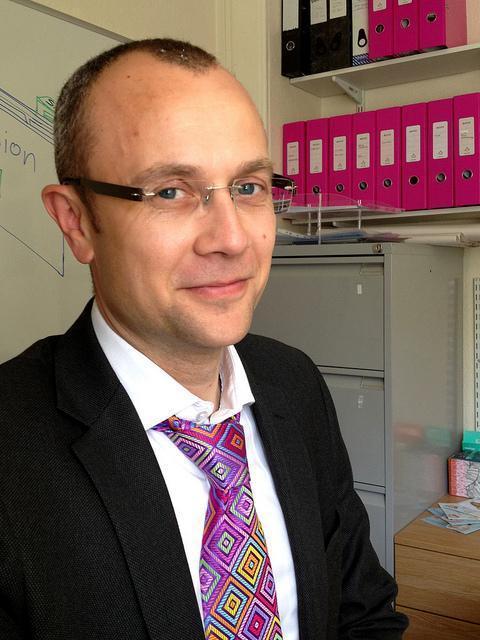How many books are there?
Give a very brief answer. 5. How many people are visible?
Give a very brief answer. 1. 